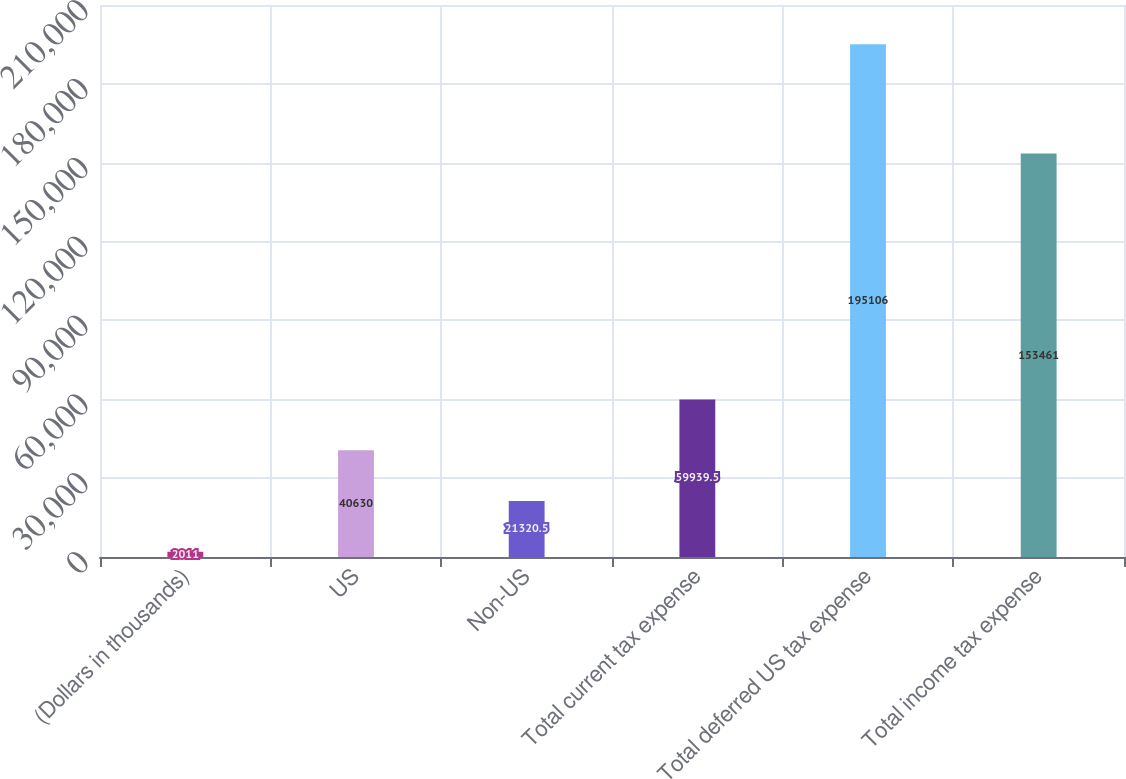<chart> <loc_0><loc_0><loc_500><loc_500><bar_chart><fcel>(Dollars in thousands)<fcel>US<fcel>Non-US<fcel>Total current tax expense<fcel>Total deferred US tax expense<fcel>Total income tax expense<nl><fcel>2011<fcel>40630<fcel>21320.5<fcel>59939.5<fcel>195106<fcel>153461<nl></chart> 